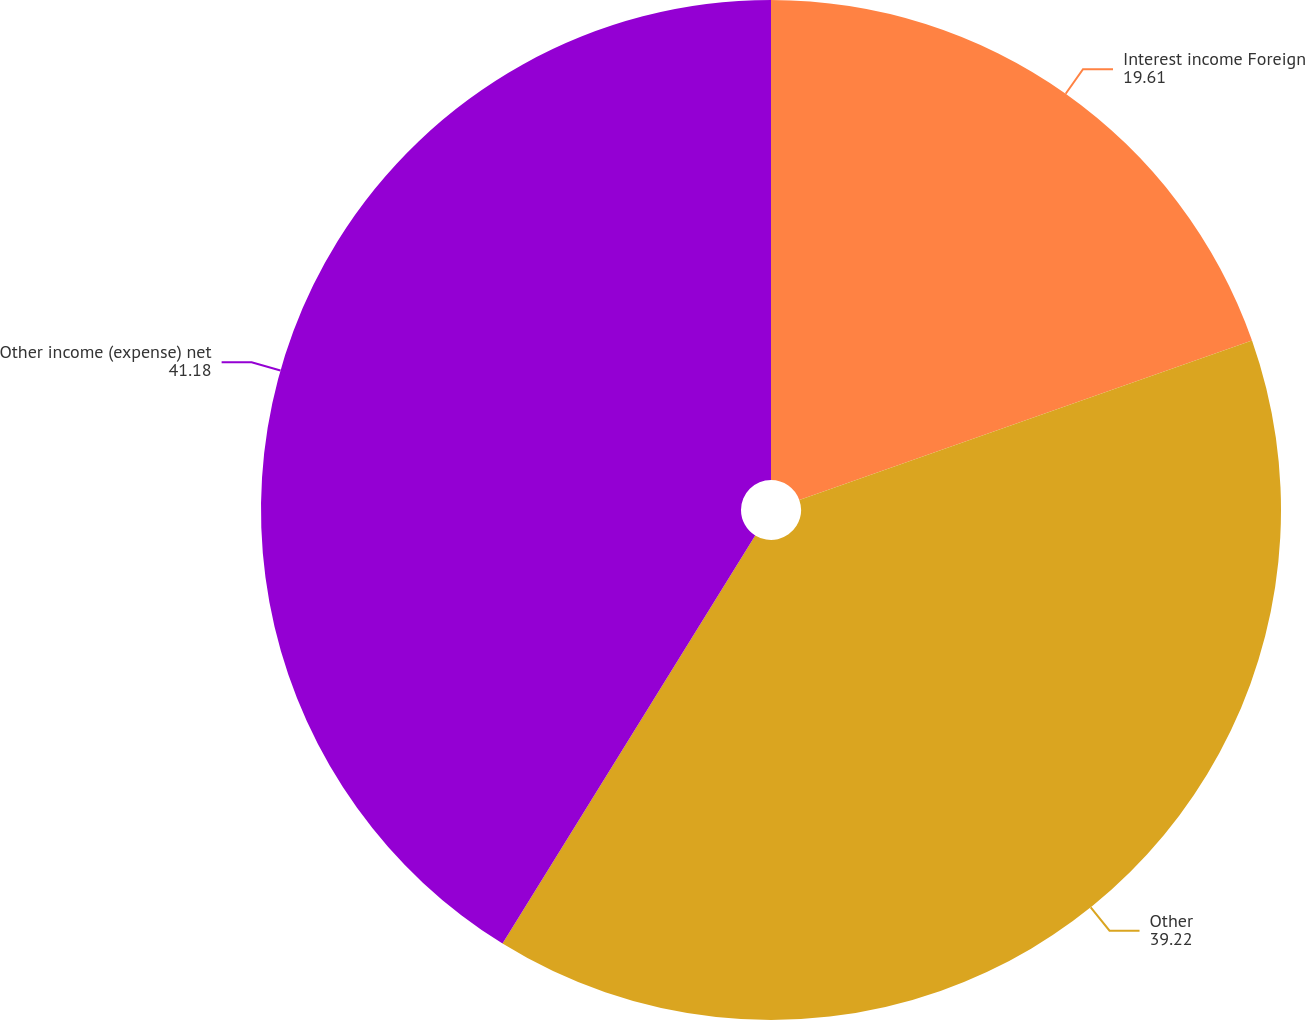<chart> <loc_0><loc_0><loc_500><loc_500><pie_chart><fcel>Interest income Foreign<fcel>Other<fcel>Other income (expense) net<nl><fcel>19.61%<fcel>39.22%<fcel>41.18%<nl></chart> 